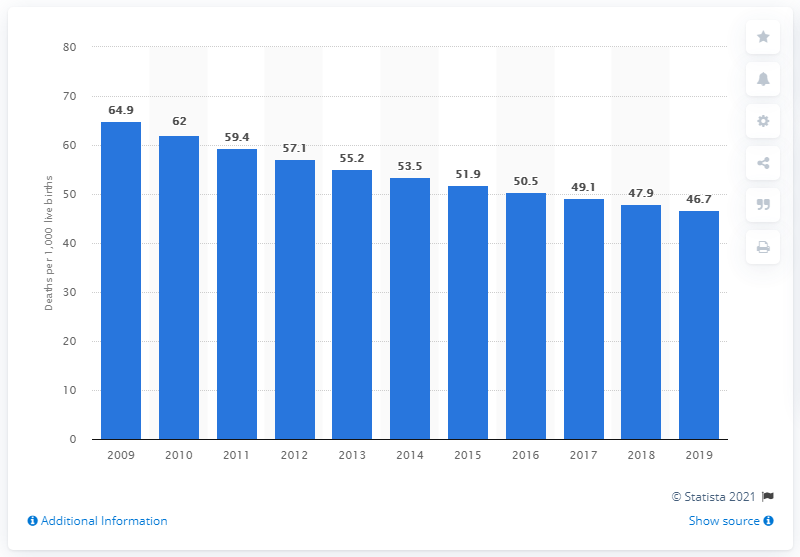Specify some key components in this picture. According to data from 2019, the infant mortality rate in Niger was 46.7 deaths per 1,000 live births. 